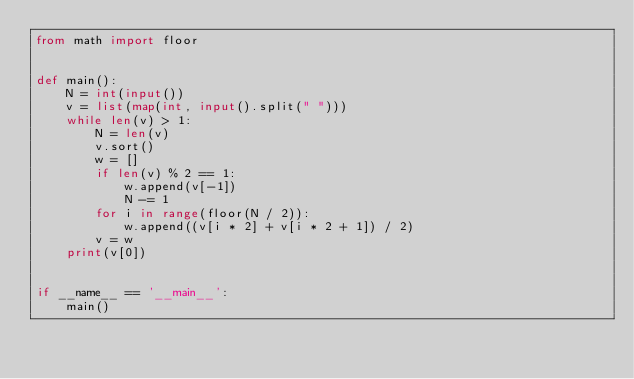<code> <loc_0><loc_0><loc_500><loc_500><_Python_>from math import floor


def main():
    N = int(input())
    v = list(map(int, input().split(" ")))
    while len(v) > 1:
        N = len(v)
        v.sort()
        w = []
        if len(v) % 2 == 1:
            w.append(v[-1])
            N -= 1
        for i in range(floor(N / 2)):
            w.append((v[i * 2] + v[i * 2 + 1]) / 2)
        v = w
    print(v[0])


if __name__ == '__main__':
    main()</code> 